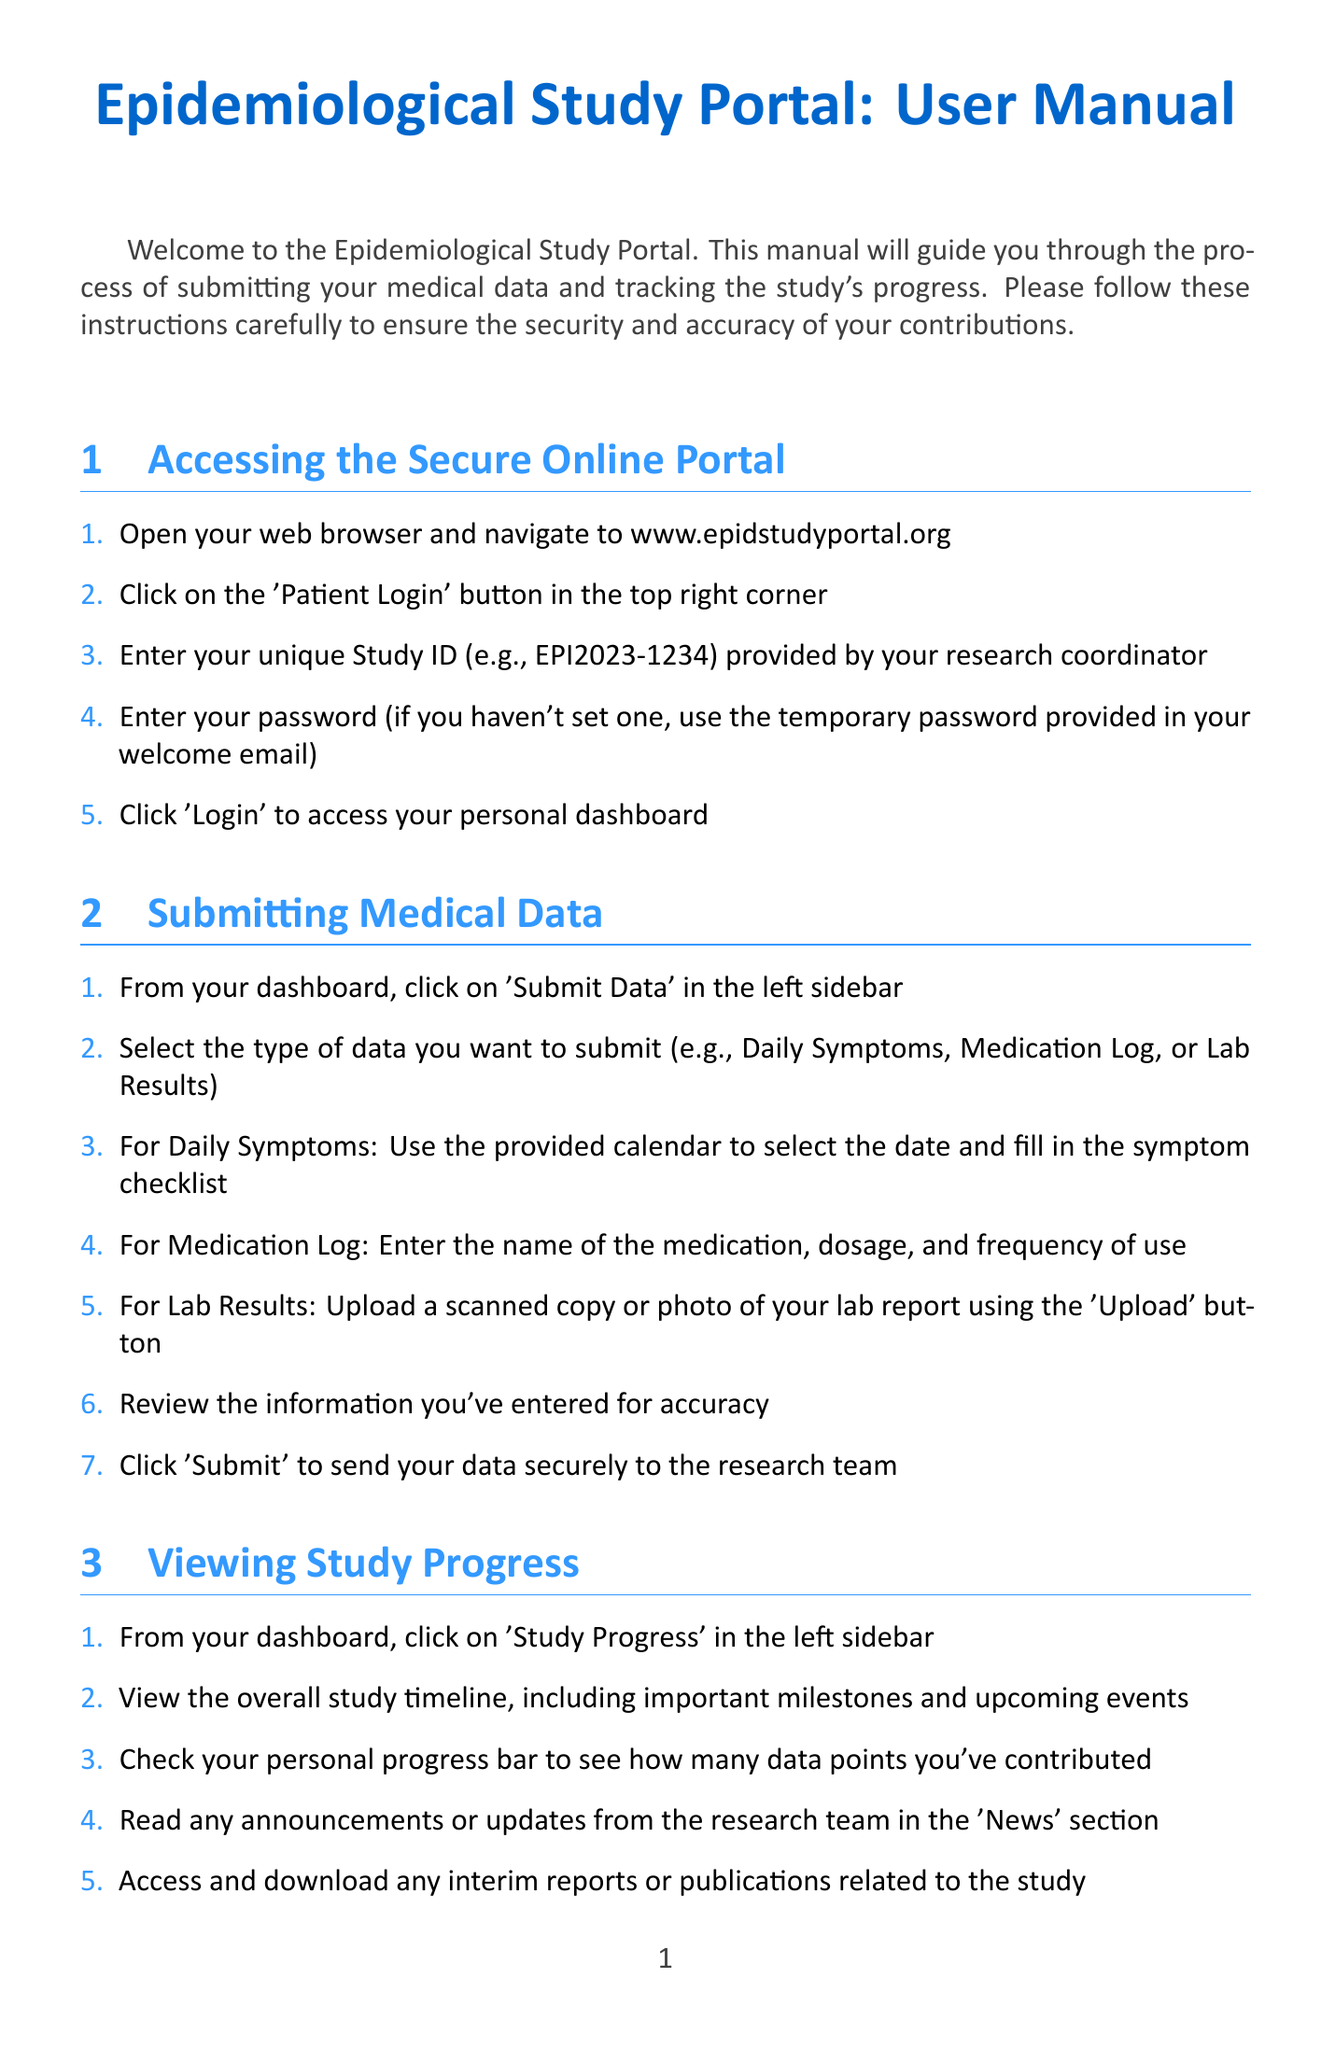what is the website to access the portal? The document provides specific instructions to open the web browser and navigate to the website for the portal, which is www.epidstudyportal.org.
Answer: www.epidstudyportal.org how do I submit my daily symptoms data? The document outlines the process of submitting various types of medical data, including a specific method for Daily Symptoms that involves using a calendar and filling in a checklist.
Answer: Use the provided calendar to select the date and fill in the symptom checklist what should I do if I forget my password? The manual indicates that if a password hasn't been set, a temporary password is provided in the welcome email for logging in.
Answer: Use the temporary password how can I see my personal progress in the study? There are specific steps mentioned in the document detailing how to view the study progress, including checking a personal progress bar.
Answer: Click on 'Study Progress' and check your personal progress bar what is the support hotline number? The document states a specific hotline number for urgent support matters that participants can call for assistance.
Answer: 1-800-EPI-HELP how can I update my contact information? The manual instructs users to access their account settings to update personal information.
Answer: Select 'Account Settings' from the dropdown menu what should I do after finishing using the portal? The document advises logging out after use to ensure security and privacy.
Answer: Click 'Logout' how can I enhance my account's security? Specific steps are mentioned in the document for increasing account security, including two-factor authentication.
Answer: Set up two-factor authentication for enhanced security what should I do if I notice suspicious activity? The manual instructs users to report any suspicious activity to the research team immediately to ensure data security.
Answer: Report any suspicious activity or potential data breaches to the research team immediately 